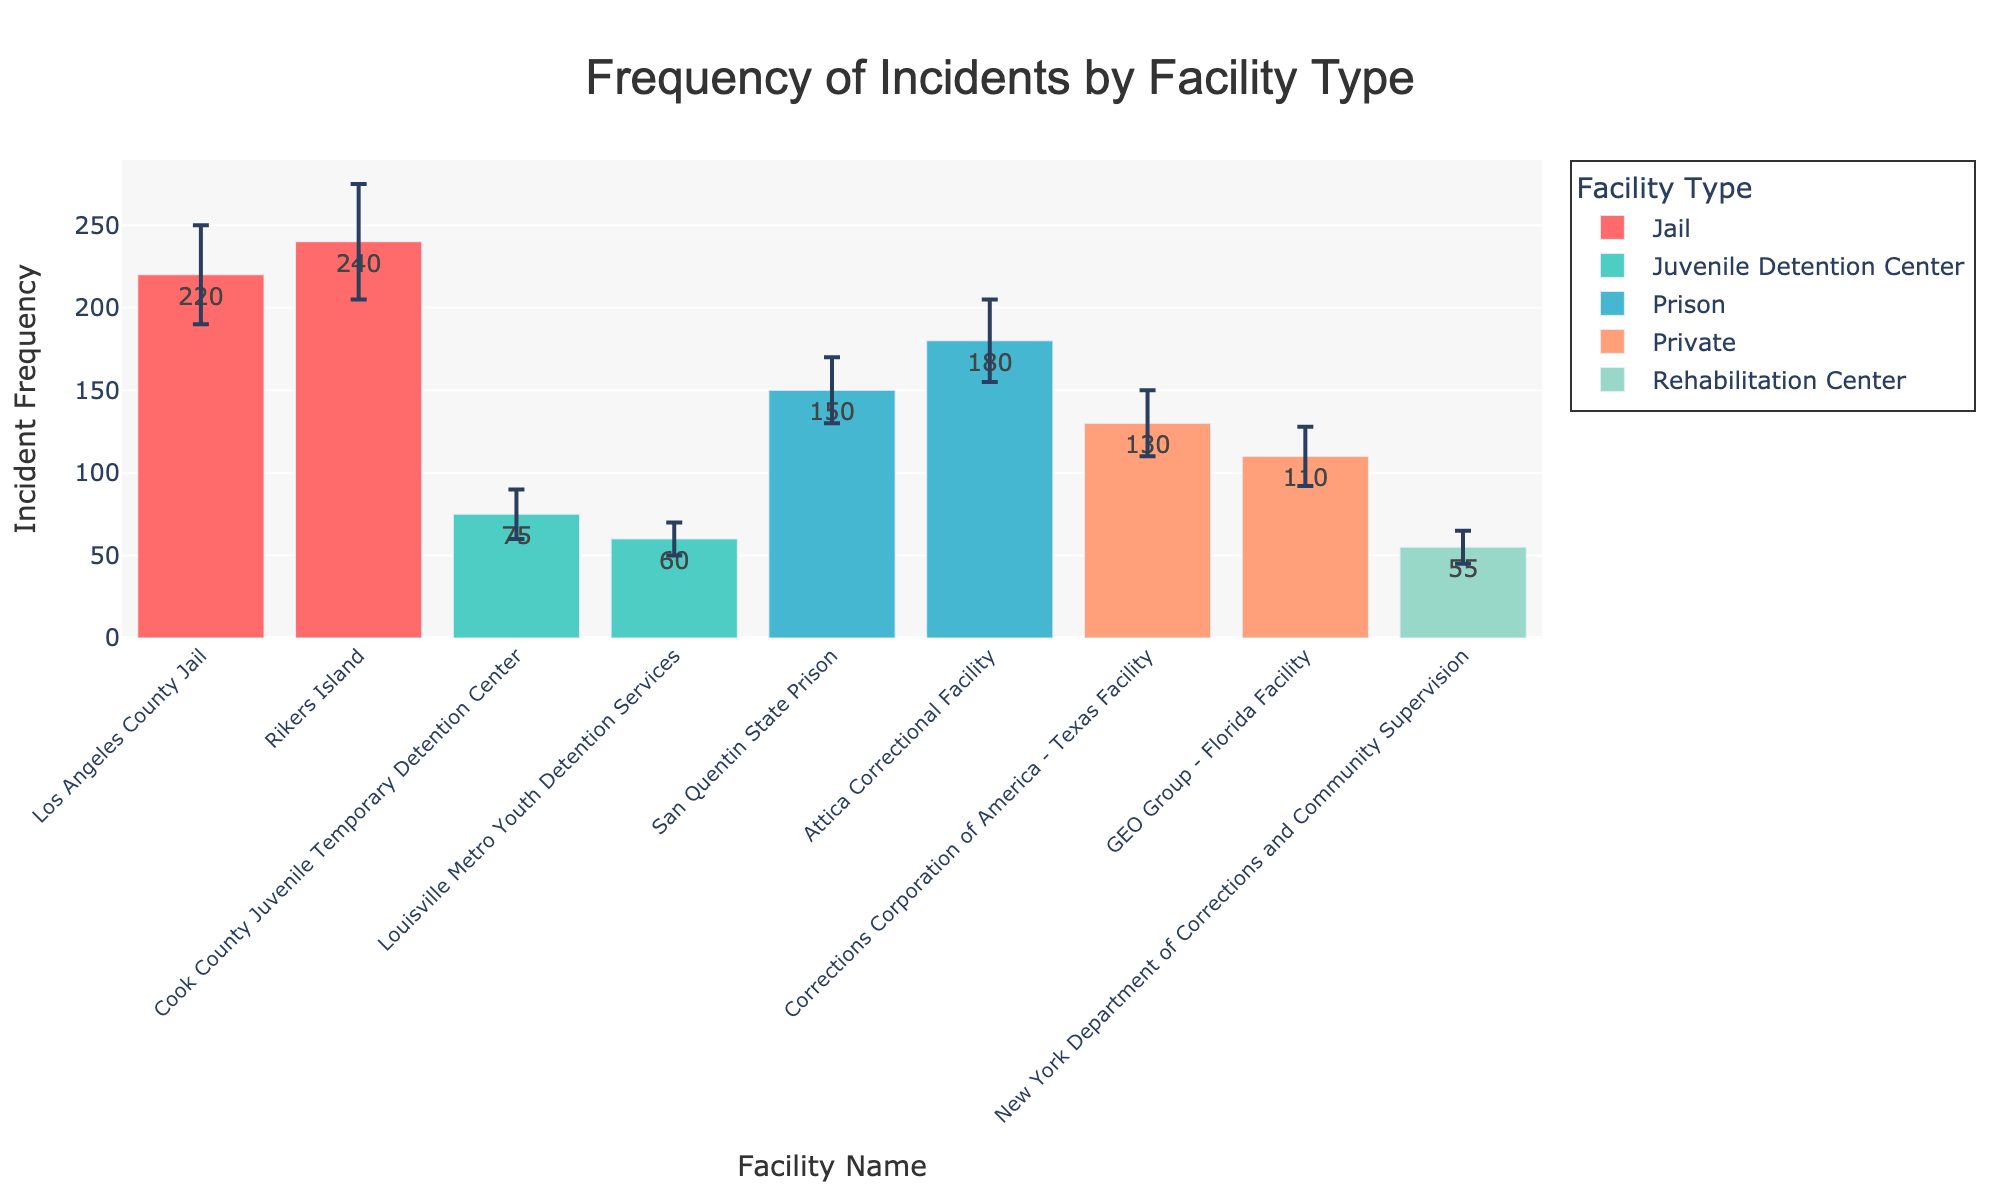What's the title of the bar chart? The title of the bar chart is usually prominently displayed at the top of the figure. In this image, it reads "Frequency of Incidents by Facility Type."
Answer: Frequency of Incidents by Facility Type How many facility types are represented in the chart? The facility types are usually listed in the legend or can be derived from the colors used in the bars. In this chart, there are five facility types: Prison, Juvenile Detention Center, Jail, Private, and Rehabilitation Center.
Answer: 5 Which facility has the highest incident frequency? Look at the y-values (incident frequency) for each bar. The facility with the tallest bar is Rikers Island.
Answer: Rikers Island What is the incident frequency and reporting uncertainty for San Quentin State Prison? Find the bar corresponding to San Quentin State Prison and note its height and error bar. The incident frequency is 150 and the reporting uncertainty is 20.
Answer: 150, 20 Which facility type has the smallest range of incident frequencies? Consider the range of incident frequencies within each facility type. The Juvenile Detention Center has frequencies ranging from 60 to 75, making it the smallest range (15).
Answer: Juvenile Detention Center What is the total incident frequency for all facilities combined? Sum the incident frequencies for all the facilities: 150 + 180 + 75 + 60 + 220 + 240 + 130 + 110 + 65 + 55 = 1285.
Answer: 1285 How do the incident frequencies of Cook County Juvenile Temporary Detention Center and Louisville Metro Youth Detention Services compare? Look at the bars for both facilities. Cook County Juvenile Temporary Detention Center has a frequency of 75 and Louisville Metro Youth Detention Services has a frequency of 60. 75 is greater than 60.
Answer: Cook County Juvenile Temporary Detention Center > Louisville Metro Youth Detention Services Which facility type has the largest average incident frequency? Calculate the average frequency for each type: 
- Prison: (150 + 180) / 2 = 165
- Juvenile Detention Center: (75 + 60) / 2 = 67.5
- Jail: (220 + 240) / 2 = 230
- Private: (130 + 110) / 2 = 120
- Rehabilitation Center: (65 + 55) / 2 = 60
The largest average is for Jails.
Answer: Jail How does the reporting uncertainty of Attica Correctional Facility compare to that of GEO Group - Florida Facility? Look at the error bars for both facilities. Attica Correctional Facility has an uncertainty of 25 and GEO Group - Florida Facility has an uncertainty of 18. 25 is greater than 18.
Answer: Attica Correctional Facility > GEO Group - Florida Facility What is the difference in incident frequency between Los Angeles County Jail and California Substance Abuse Treatment Facility? Subtract the incident frequency of California Substance Abuse Treatment Facility (65) from Los Angeles County Jail (220): 220 - 65 = 155.
Answer: 155 